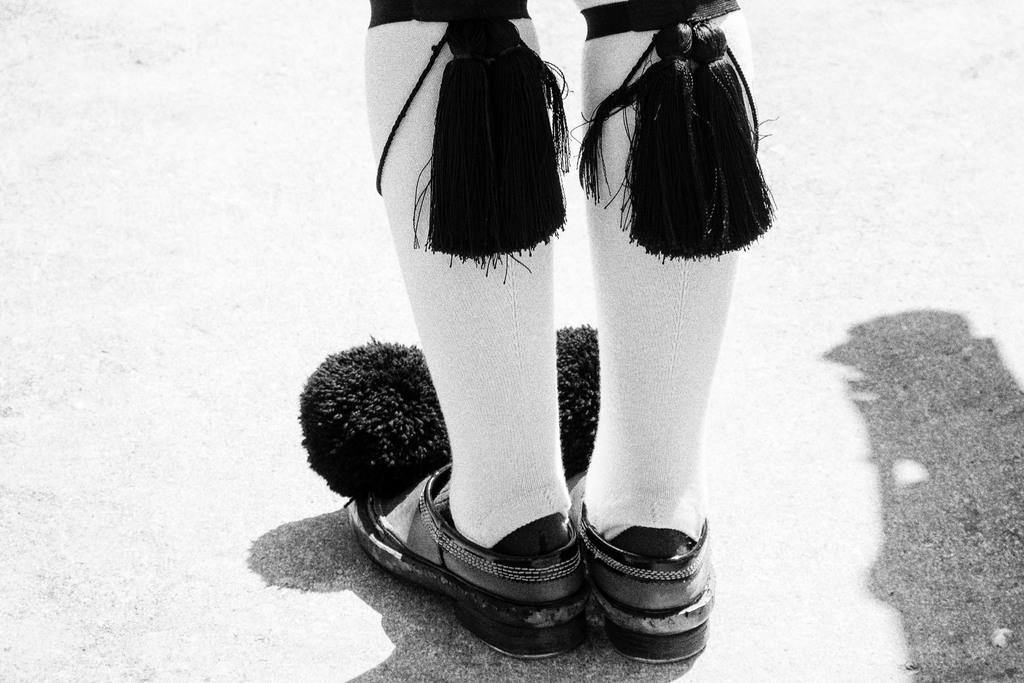What is the color scheme of the image? The image is black and white. What part of a person can be seen in the image? The legs of a person are visible in the image. What type of footwear is the person wearing? The person is wearing shoes. What type of cake is being served on the side in the image? There is no cake present in the image; it is a black and white and features the legs of a person wearing shoes. 